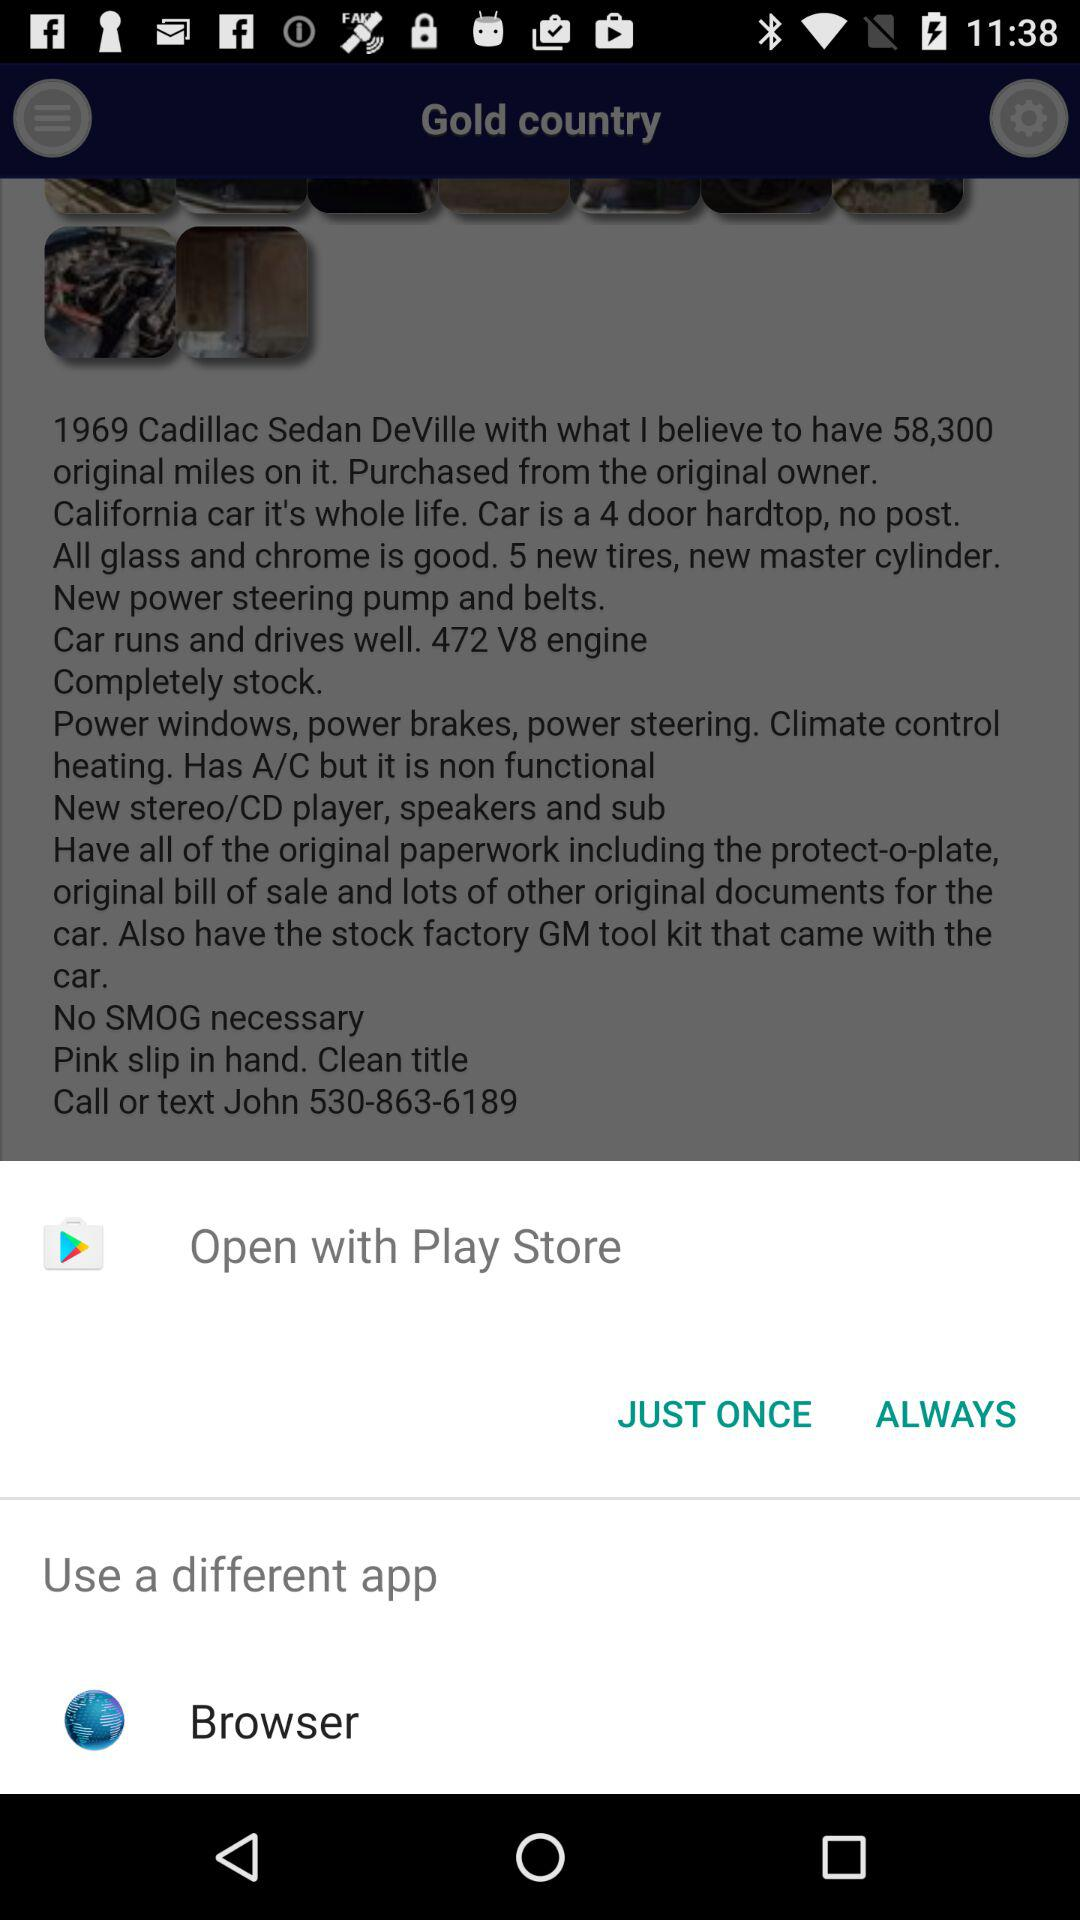What options are given to open it? The options given are "Play Store" and "Browser". 